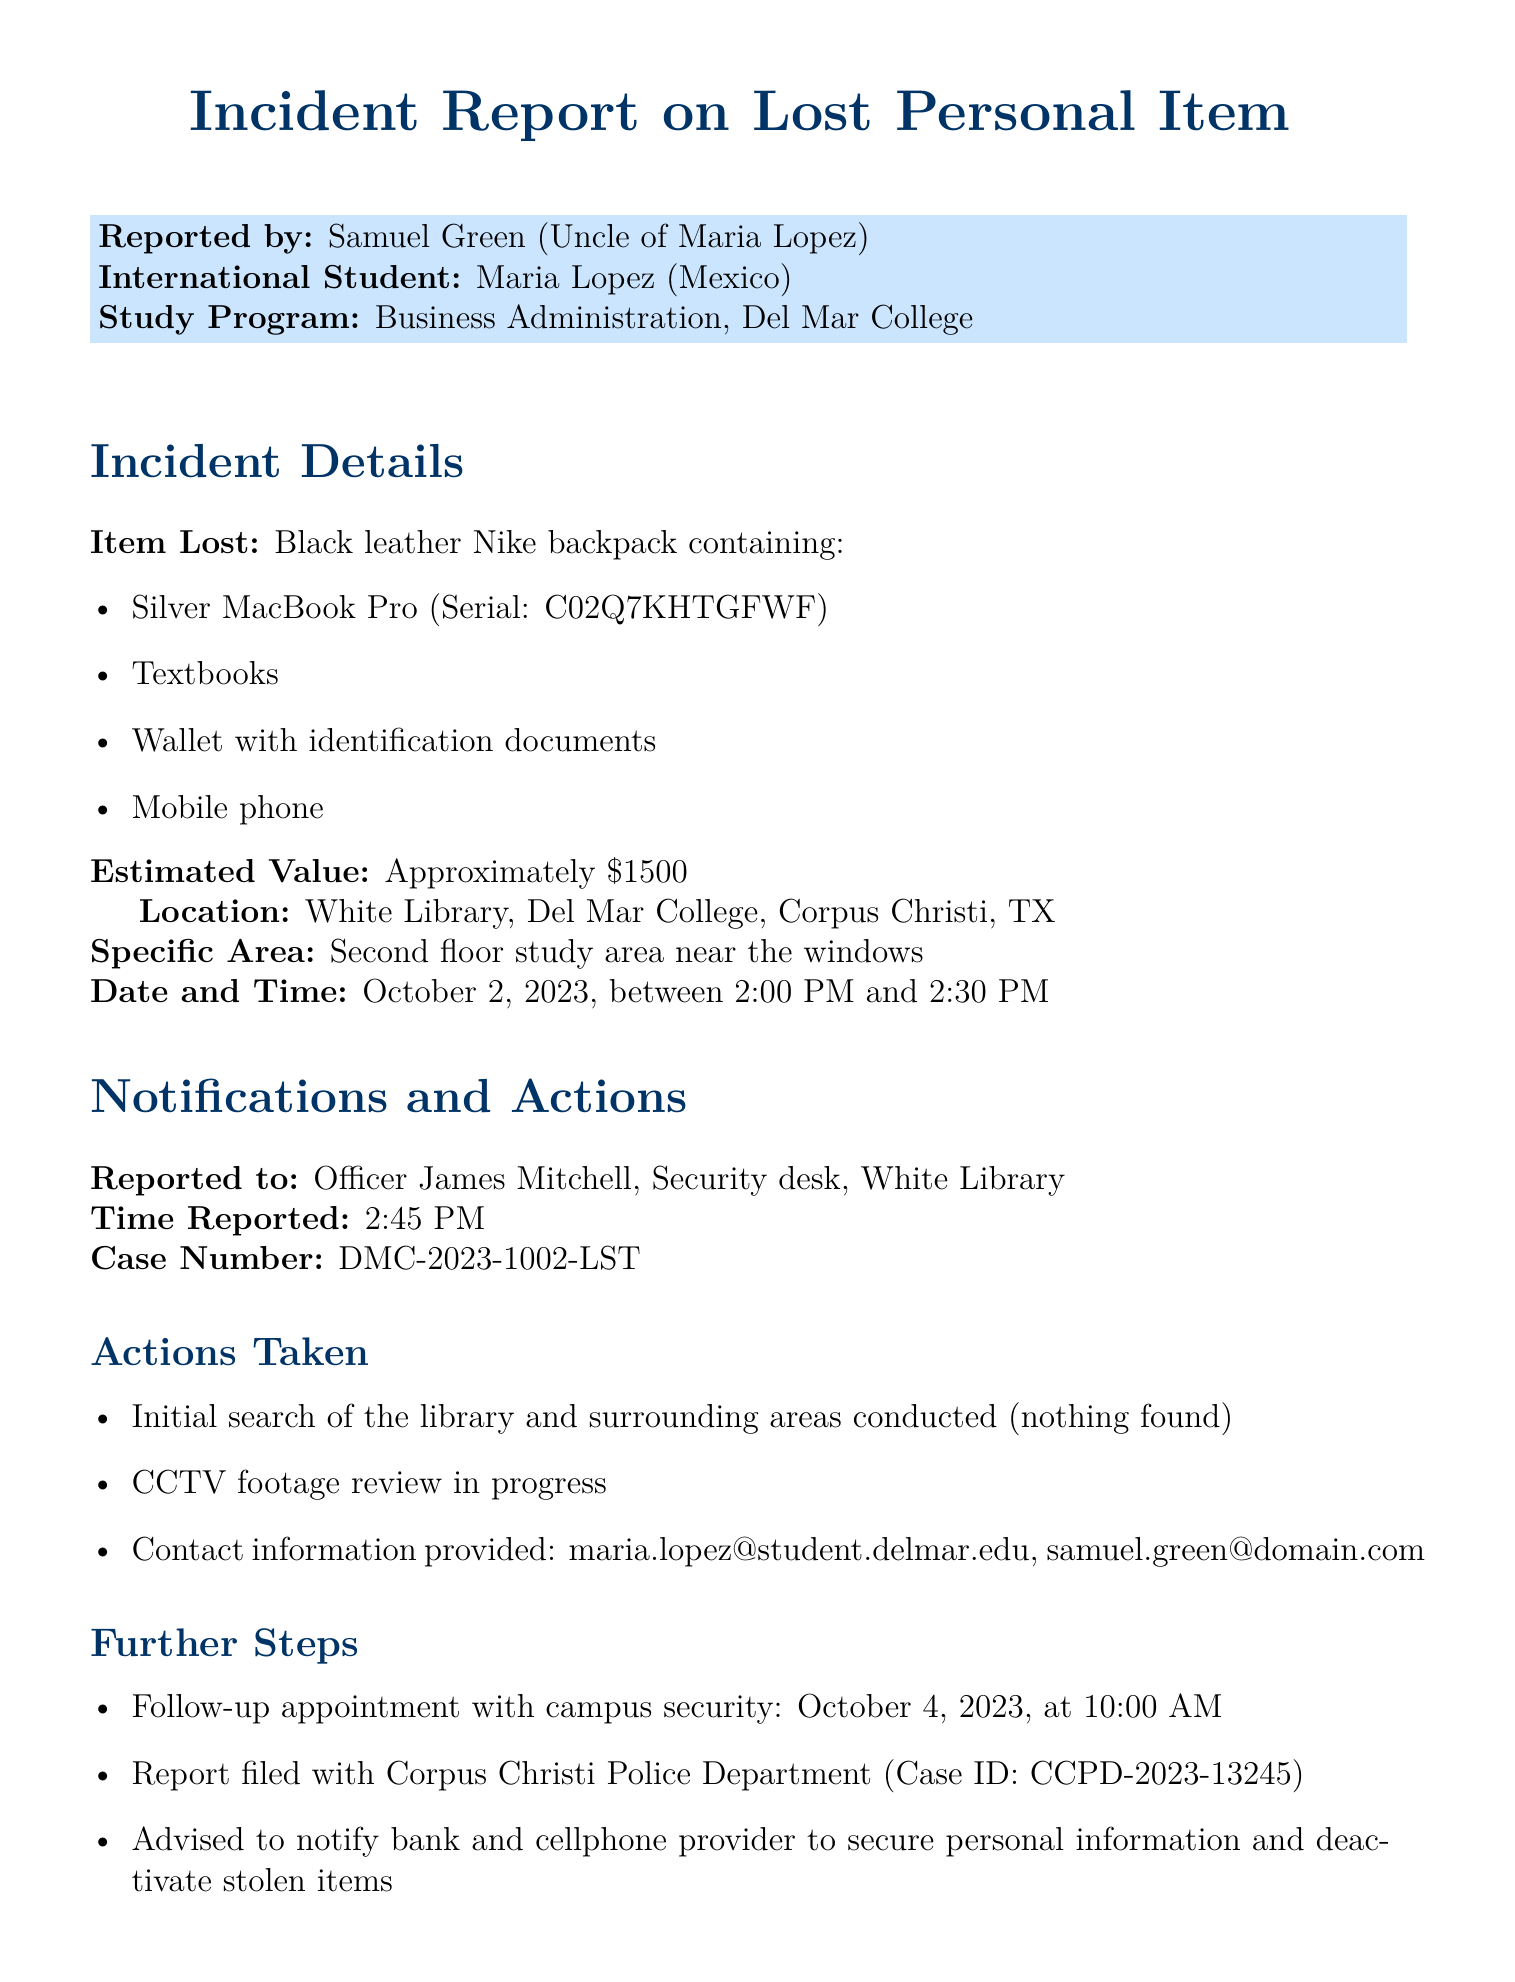What item was lost? The report lists the specific item that was lost, which is a black leather Nike backpack containing several items.
Answer: Black leather Nike backpack What is the estimated value of the lost items? The estimated value of all items lost is stated in the document.
Answer: Approximately $1500 Where did the incident occur? The document specifies the location of the lost item.
Answer: White Library, Del Mar College Who was the incident reported to? The report identifies the security officer whom the incident was reported to.
Answer: Officer James Mitchell What time was the item reported lost? The specific time at which the incident was reported to security is noted in the report.
Answer: 2:45 PM What further steps were advised for personal information security? The report outlines actions advised to the student regarding personal security after the incident.
Answer: Notify bank and cellphone provider When is the follow-up appointment with campus security scheduled? The document specifies the date and time for the follow-up appointment.
Answer: October 4, 2023, at 10:00 AM What case number was assigned to this incident? The report includes a specific case number related to the incident.
Answer: DMC-2023-1002-LST What specific items were contained in the lost backpack? The report lists the contents of the backpack, which helps in identifying it.
Answer: Silver MacBook Pro, textbooks, wallet, mobile phone 